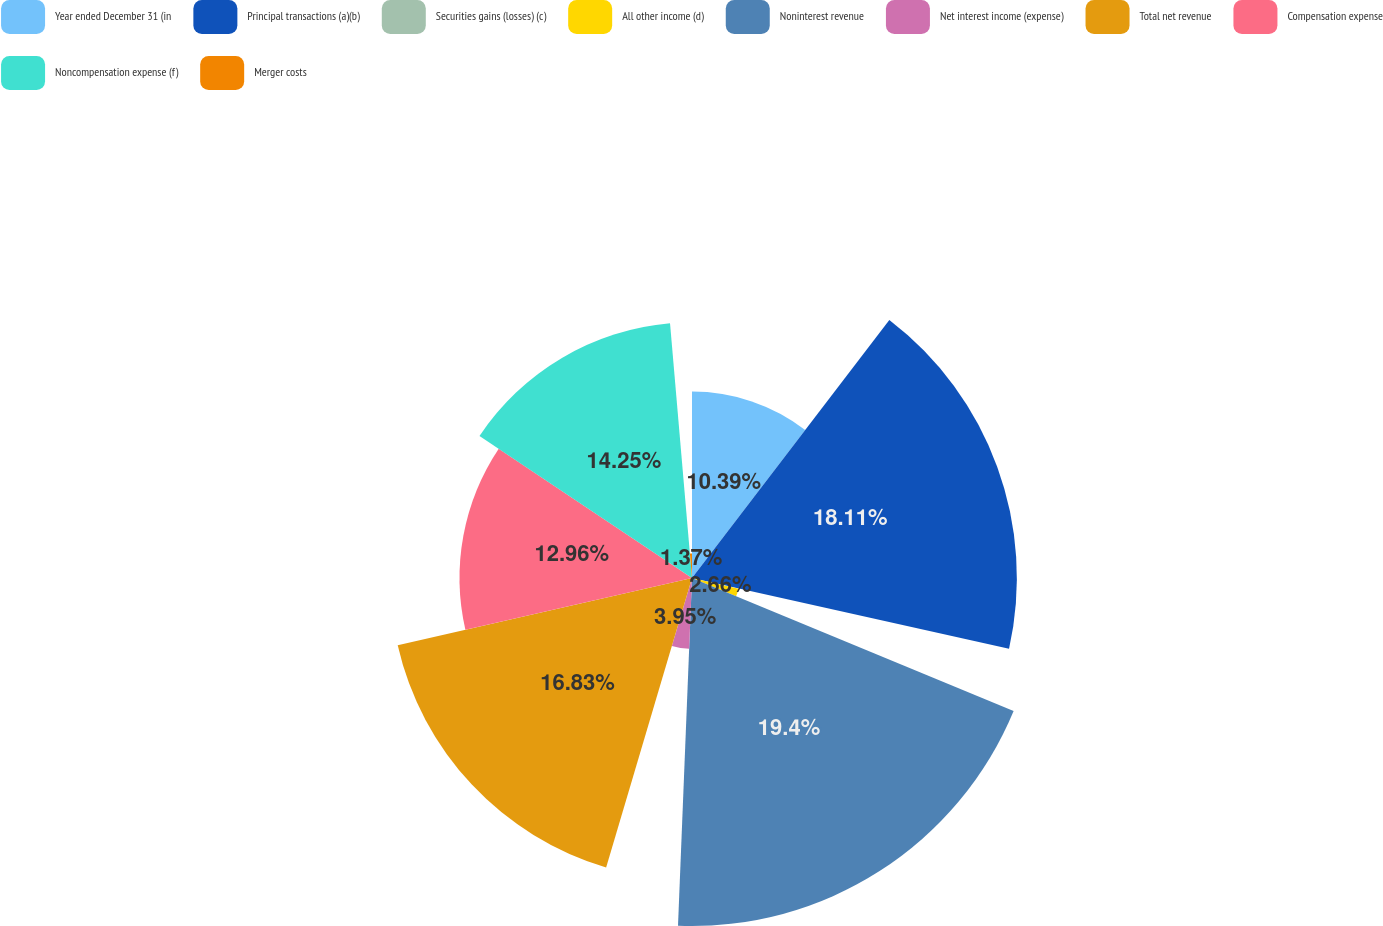<chart> <loc_0><loc_0><loc_500><loc_500><pie_chart><fcel>Year ended December 31 (in<fcel>Principal transactions (a)(b)<fcel>Securities gains (losses) (c)<fcel>All other income (d)<fcel>Noninterest revenue<fcel>Net interest income (expense)<fcel>Total net revenue<fcel>Compensation expense<fcel>Noncompensation expense (f)<fcel>Merger costs<nl><fcel>10.39%<fcel>18.11%<fcel>0.08%<fcel>2.66%<fcel>19.4%<fcel>3.95%<fcel>16.83%<fcel>12.96%<fcel>14.25%<fcel>1.37%<nl></chart> 